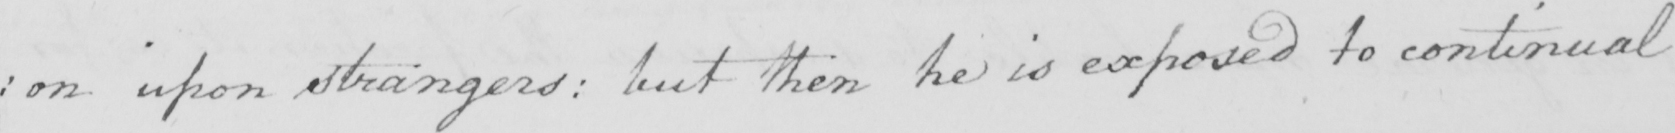Can you read and transcribe this handwriting? : on upon strangers :  but then he is exposed to continual 